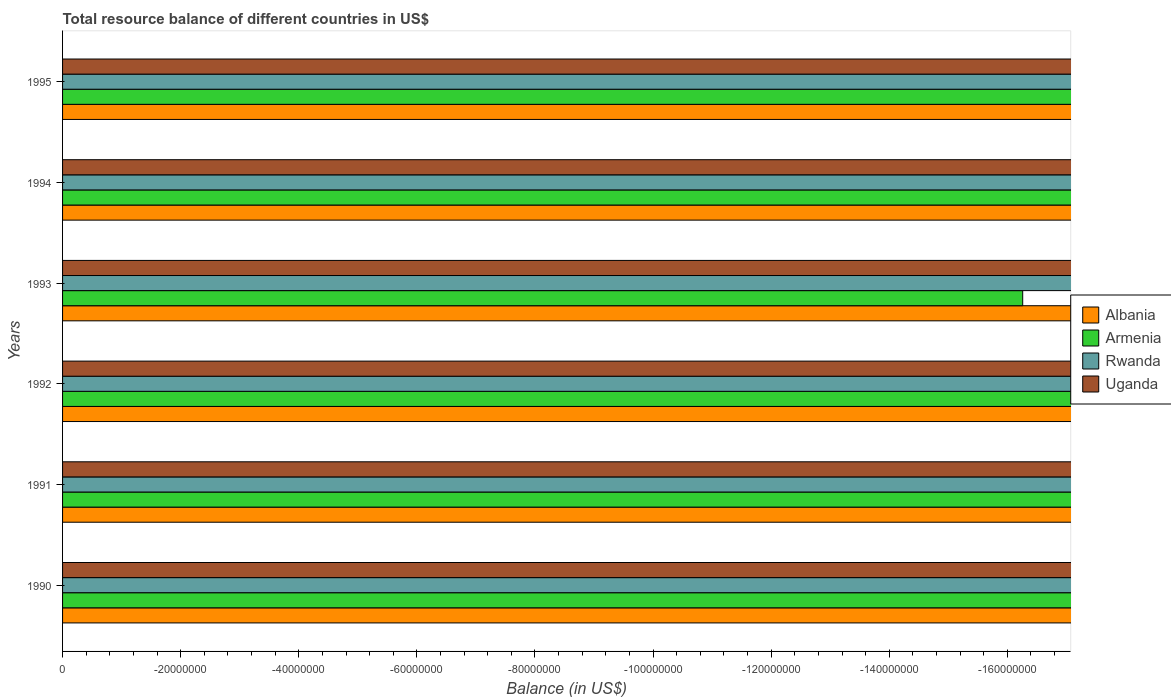Are the number of bars on each tick of the Y-axis equal?
Make the answer very short. Yes. How many bars are there on the 3rd tick from the top?
Provide a short and direct response. 0. How many bars are there on the 2nd tick from the bottom?
Keep it short and to the point. 0. What is the total resource balance in Armenia in 1994?
Ensure brevity in your answer.  0. Across all years, what is the minimum total resource balance in Uganda?
Offer a very short reply. 0. What is the total total resource balance in Rwanda in the graph?
Provide a succinct answer. 0. Is it the case that in every year, the sum of the total resource balance in Albania and total resource balance in Armenia is greater than the total resource balance in Uganda?
Offer a terse response. No. How many bars are there?
Your answer should be compact. 0. How many years are there in the graph?
Your response must be concise. 6. What is the difference between two consecutive major ticks on the X-axis?
Provide a succinct answer. 2.00e+07. Does the graph contain grids?
Offer a very short reply. No. How many legend labels are there?
Give a very brief answer. 4. What is the title of the graph?
Keep it short and to the point. Total resource balance of different countries in US$. What is the label or title of the X-axis?
Your answer should be compact. Balance (in US$). What is the Balance (in US$) in Albania in 1990?
Ensure brevity in your answer.  0. What is the Balance (in US$) in Armenia in 1990?
Ensure brevity in your answer.  0. What is the Balance (in US$) in Rwanda in 1990?
Keep it short and to the point. 0. What is the Balance (in US$) of Albania in 1991?
Make the answer very short. 0. What is the Balance (in US$) of Armenia in 1991?
Offer a terse response. 0. What is the Balance (in US$) of Rwanda in 1991?
Make the answer very short. 0. What is the Balance (in US$) of Uganda in 1991?
Provide a short and direct response. 0. What is the Balance (in US$) of Albania in 1992?
Provide a short and direct response. 0. What is the Balance (in US$) of Rwanda in 1992?
Keep it short and to the point. 0. What is the Balance (in US$) of Armenia in 1993?
Make the answer very short. 0. What is the Balance (in US$) in Rwanda in 1993?
Offer a very short reply. 0. What is the Balance (in US$) of Uganda in 1993?
Your response must be concise. 0. What is the Balance (in US$) in Albania in 1994?
Your answer should be compact. 0. What is the Balance (in US$) in Rwanda in 1994?
Ensure brevity in your answer.  0. What is the Balance (in US$) of Uganda in 1994?
Ensure brevity in your answer.  0. What is the total Balance (in US$) of Armenia in the graph?
Your answer should be compact. 0. What is the average Balance (in US$) in Armenia per year?
Make the answer very short. 0. What is the average Balance (in US$) in Rwanda per year?
Give a very brief answer. 0. What is the average Balance (in US$) in Uganda per year?
Offer a very short reply. 0. 